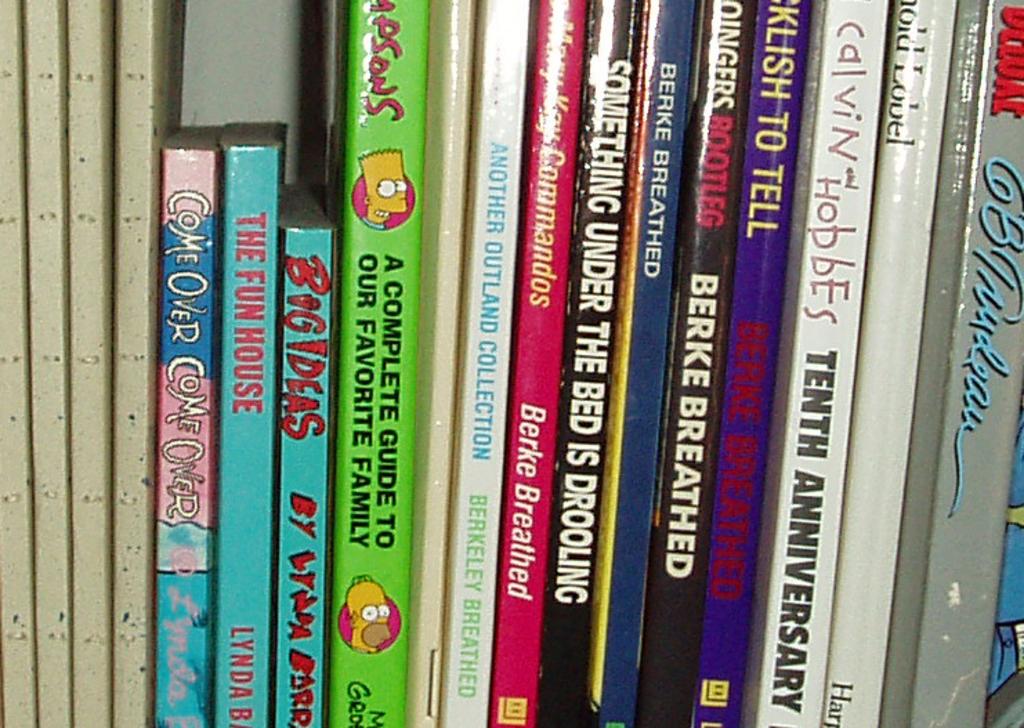A complete guide to what?
Provide a short and direct response. Our favorite family. What anniversary is the calvin and hobbes book?
Your response must be concise. Tenth. 